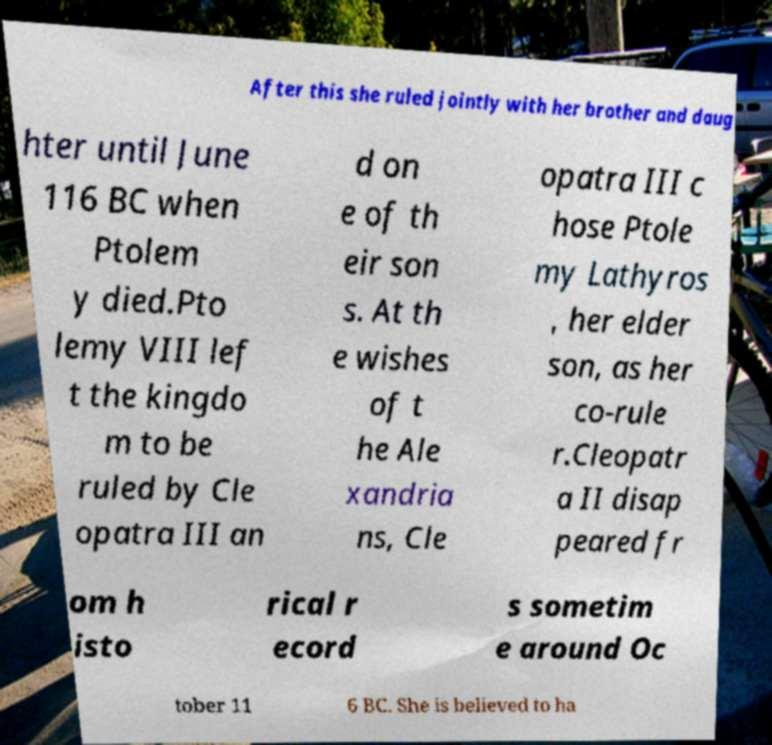For documentation purposes, I need the text within this image transcribed. Could you provide that? After this she ruled jointly with her brother and daug hter until June 116 BC when Ptolem y died.Pto lemy VIII lef t the kingdo m to be ruled by Cle opatra III an d on e of th eir son s. At th e wishes of t he Ale xandria ns, Cle opatra III c hose Ptole my Lathyros , her elder son, as her co-rule r.Cleopatr a II disap peared fr om h isto rical r ecord s sometim e around Oc tober 11 6 BC. She is believed to ha 